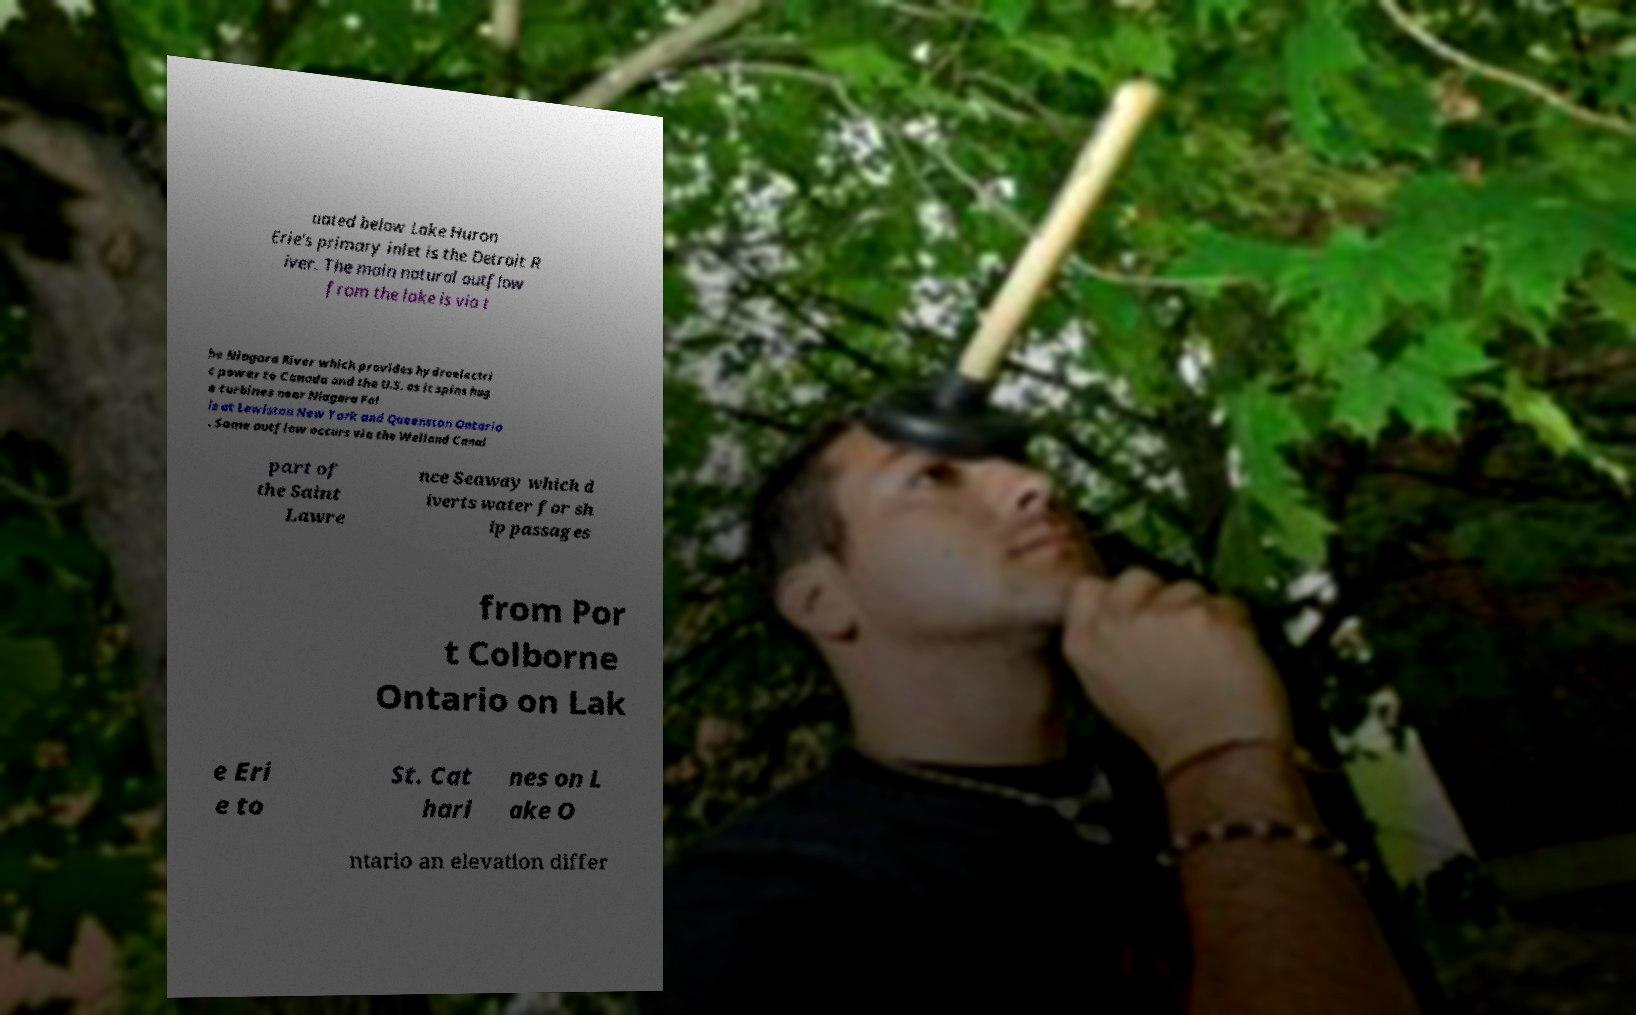Could you assist in decoding the text presented in this image and type it out clearly? uated below Lake Huron Erie's primary inlet is the Detroit R iver. The main natural outflow from the lake is via t he Niagara River which provides hydroelectri c power to Canada and the U.S. as it spins hug e turbines near Niagara Fal ls at Lewiston New York and Queenston Ontario . Some outflow occurs via the Welland Canal part of the Saint Lawre nce Seaway which d iverts water for sh ip passages from Por t Colborne Ontario on Lak e Eri e to St. Cat hari nes on L ake O ntario an elevation differ 